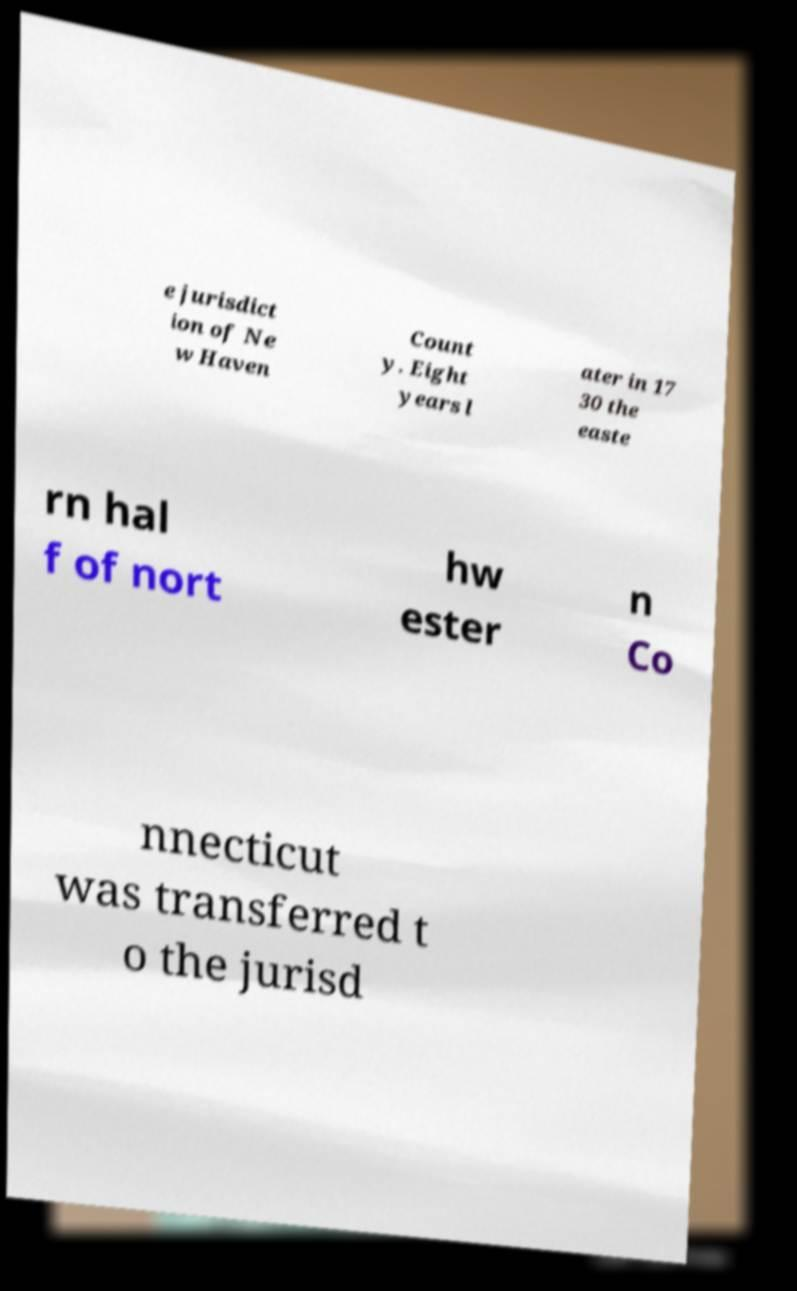I need the written content from this picture converted into text. Can you do that? e jurisdict ion of Ne w Haven Count y. Eight years l ater in 17 30 the easte rn hal f of nort hw ester n Co nnecticut was transferred t o the jurisd 